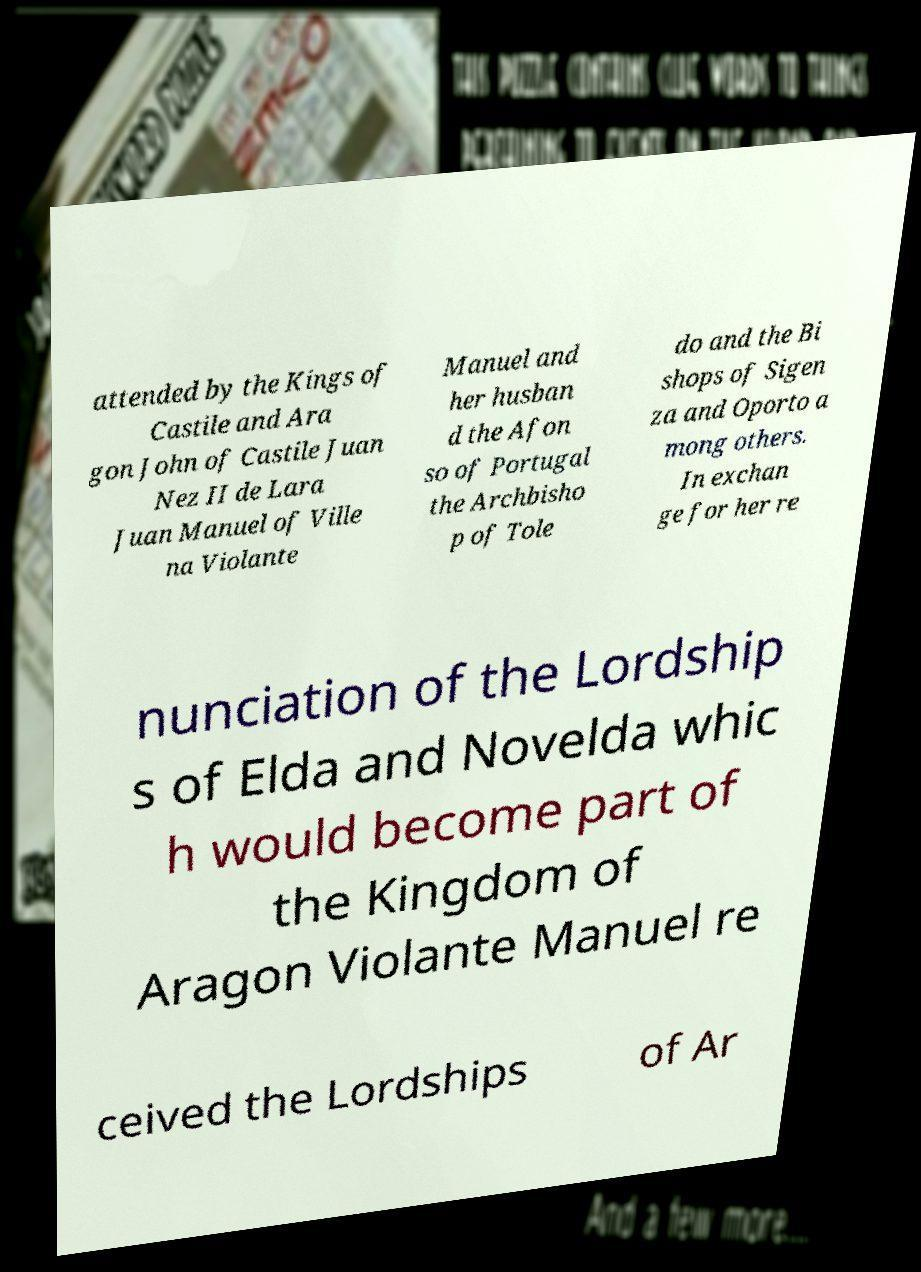Can you accurately transcribe the text from the provided image for me? attended by the Kings of Castile and Ara gon John of Castile Juan Nez II de Lara Juan Manuel of Ville na Violante Manuel and her husban d the Afon so of Portugal the Archbisho p of Tole do and the Bi shops of Sigen za and Oporto a mong others. In exchan ge for her re nunciation of the Lordship s of Elda and Novelda whic h would become part of the Kingdom of Aragon Violante Manuel re ceived the Lordships of Ar 